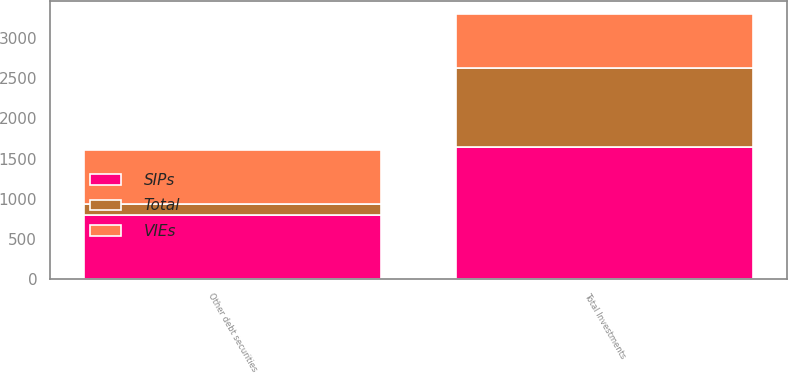Convert chart to OTSL. <chart><loc_0><loc_0><loc_500><loc_500><stacked_bar_chart><ecel><fcel>Other debt securities<fcel>Total Investments<nl><fcel>Total<fcel>129.2<fcel>977.4<nl><fcel>VIEs<fcel>672.5<fcel>672.5<nl><fcel>SIPs<fcel>801.7<fcel>1649.9<nl></chart> 